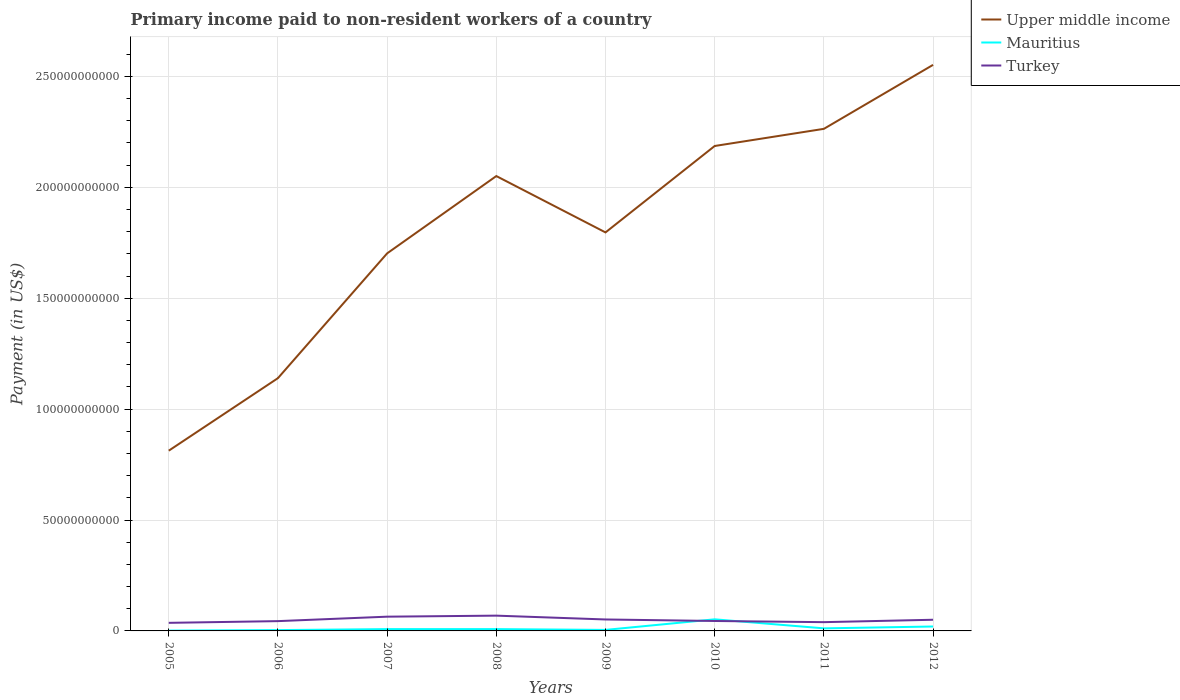Is the number of lines equal to the number of legend labels?
Give a very brief answer. Yes. Across all years, what is the maximum amount paid to workers in Turkey?
Your response must be concise. 3.64e+09. What is the total amount paid to workers in Upper middle income in the graph?
Offer a terse response. -1.45e+11. What is the difference between the highest and the second highest amount paid to workers in Turkey?
Give a very brief answer. 3.24e+09. Is the amount paid to workers in Turkey strictly greater than the amount paid to workers in Upper middle income over the years?
Provide a succinct answer. Yes. How many lines are there?
Give a very brief answer. 3. How many years are there in the graph?
Give a very brief answer. 8. What is the difference between two consecutive major ticks on the Y-axis?
Provide a short and direct response. 5.00e+1. Are the values on the major ticks of Y-axis written in scientific E-notation?
Your response must be concise. No. Does the graph contain any zero values?
Give a very brief answer. No. Does the graph contain grids?
Offer a very short reply. Yes. What is the title of the graph?
Offer a very short reply. Primary income paid to non-resident workers of a country. Does "Pacific island small states" appear as one of the legend labels in the graph?
Offer a terse response. No. What is the label or title of the Y-axis?
Your response must be concise. Payment (in US$). What is the Payment (in US$) in Upper middle income in 2005?
Offer a terse response. 8.13e+1. What is the Payment (in US$) in Mauritius in 2005?
Offer a very short reply. 1.43e+08. What is the Payment (in US$) in Turkey in 2005?
Provide a succinct answer. 3.64e+09. What is the Payment (in US$) in Upper middle income in 2006?
Keep it short and to the point. 1.14e+11. What is the Payment (in US$) of Mauritius in 2006?
Make the answer very short. 3.74e+08. What is the Payment (in US$) of Turkey in 2006?
Make the answer very short. 4.42e+09. What is the Payment (in US$) of Upper middle income in 2007?
Make the answer very short. 1.70e+11. What is the Payment (in US$) in Mauritius in 2007?
Ensure brevity in your answer.  8.16e+08. What is the Payment (in US$) in Turkey in 2007?
Your answer should be very brief. 6.42e+09. What is the Payment (in US$) of Upper middle income in 2008?
Offer a very short reply. 2.05e+11. What is the Payment (in US$) in Mauritius in 2008?
Offer a very short reply. 8.20e+08. What is the Payment (in US$) in Turkey in 2008?
Give a very brief answer. 6.89e+09. What is the Payment (in US$) in Upper middle income in 2009?
Ensure brevity in your answer.  1.80e+11. What is the Payment (in US$) in Mauritius in 2009?
Keep it short and to the point. 4.58e+08. What is the Payment (in US$) in Turkey in 2009?
Offer a very short reply. 5.16e+09. What is the Payment (in US$) in Upper middle income in 2010?
Your response must be concise. 2.19e+11. What is the Payment (in US$) of Mauritius in 2010?
Offer a terse response. 5.23e+09. What is the Payment (in US$) of Turkey in 2010?
Offer a very short reply. 4.48e+09. What is the Payment (in US$) of Upper middle income in 2011?
Provide a succinct answer. 2.26e+11. What is the Payment (in US$) in Mauritius in 2011?
Make the answer very short. 1.16e+09. What is the Payment (in US$) of Turkey in 2011?
Offer a terse response. 3.95e+09. What is the Payment (in US$) in Upper middle income in 2012?
Your answer should be very brief. 2.55e+11. What is the Payment (in US$) in Mauritius in 2012?
Offer a terse response. 1.99e+09. What is the Payment (in US$) in Turkey in 2012?
Your response must be concise. 5.03e+09. Across all years, what is the maximum Payment (in US$) of Upper middle income?
Provide a succinct answer. 2.55e+11. Across all years, what is the maximum Payment (in US$) in Mauritius?
Offer a terse response. 5.23e+09. Across all years, what is the maximum Payment (in US$) of Turkey?
Your answer should be compact. 6.89e+09. Across all years, what is the minimum Payment (in US$) in Upper middle income?
Keep it short and to the point. 8.13e+1. Across all years, what is the minimum Payment (in US$) of Mauritius?
Provide a short and direct response. 1.43e+08. Across all years, what is the minimum Payment (in US$) in Turkey?
Make the answer very short. 3.64e+09. What is the total Payment (in US$) in Upper middle income in the graph?
Ensure brevity in your answer.  1.45e+12. What is the total Payment (in US$) of Mauritius in the graph?
Give a very brief answer. 1.10e+1. What is the total Payment (in US$) of Turkey in the graph?
Offer a very short reply. 4.00e+1. What is the difference between the Payment (in US$) in Upper middle income in 2005 and that in 2006?
Your response must be concise. -3.27e+1. What is the difference between the Payment (in US$) of Mauritius in 2005 and that in 2006?
Make the answer very short. -2.31e+08. What is the difference between the Payment (in US$) in Turkey in 2005 and that in 2006?
Your answer should be very brief. -7.74e+08. What is the difference between the Payment (in US$) of Upper middle income in 2005 and that in 2007?
Provide a succinct answer. -8.90e+1. What is the difference between the Payment (in US$) of Mauritius in 2005 and that in 2007?
Provide a succinct answer. -6.74e+08. What is the difference between the Payment (in US$) in Turkey in 2005 and that in 2007?
Offer a terse response. -2.78e+09. What is the difference between the Payment (in US$) of Upper middle income in 2005 and that in 2008?
Make the answer very short. -1.24e+11. What is the difference between the Payment (in US$) in Mauritius in 2005 and that in 2008?
Keep it short and to the point. -6.77e+08. What is the difference between the Payment (in US$) of Turkey in 2005 and that in 2008?
Offer a terse response. -3.24e+09. What is the difference between the Payment (in US$) of Upper middle income in 2005 and that in 2009?
Give a very brief answer. -9.84e+1. What is the difference between the Payment (in US$) of Mauritius in 2005 and that in 2009?
Offer a very short reply. -3.15e+08. What is the difference between the Payment (in US$) of Turkey in 2005 and that in 2009?
Your answer should be very brief. -1.52e+09. What is the difference between the Payment (in US$) of Upper middle income in 2005 and that in 2010?
Provide a succinct answer. -1.37e+11. What is the difference between the Payment (in US$) in Mauritius in 2005 and that in 2010?
Make the answer very short. -5.09e+09. What is the difference between the Payment (in US$) in Turkey in 2005 and that in 2010?
Keep it short and to the point. -8.34e+08. What is the difference between the Payment (in US$) in Upper middle income in 2005 and that in 2011?
Give a very brief answer. -1.45e+11. What is the difference between the Payment (in US$) of Mauritius in 2005 and that in 2011?
Keep it short and to the point. -1.01e+09. What is the difference between the Payment (in US$) in Turkey in 2005 and that in 2011?
Give a very brief answer. -3.08e+08. What is the difference between the Payment (in US$) of Upper middle income in 2005 and that in 2012?
Give a very brief answer. -1.74e+11. What is the difference between the Payment (in US$) in Mauritius in 2005 and that in 2012?
Give a very brief answer. -1.85e+09. What is the difference between the Payment (in US$) of Turkey in 2005 and that in 2012?
Ensure brevity in your answer.  -1.39e+09. What is the difference between the Payment (in US$) of Upper middle income in 2006 and that in 2007?
Keep it short and to the point. -5.63e+1. What is the difference between the Payment (in US$) of Mauritius in 2006 and that in 2007?
Your response must be concise. -4.42e+08. What is the difference between the Payment (in US$) in Turkey in 2006 and that in 2007?
Your answer should be compact. -2.00e+09. What is the difference between the Payment (in US$) of Upper middle income in 2006 and that in 2008?
Your answer should be very brief. -9.11e+1. What is the difference between the Payment (in US$) in Mauritius in 2006 and that in 2008?
Ensure brevity in your answer.  -4.46e+08. What is the difference between the Payment (in US$) of Turkey in 2006 and that in 2008?
Offer a terse response. -2.47e+09. What is the difference between the Payment (in US$) of Upper middle income in 2006 and that in 2009?
Your answer should be very brief. -6.57e+1. What is the difference between the Payment (in US$) of Mauritius in 2006 and that in 2009?
Offer a terse response. -8.37e+07. What is the difference between the Payment (in US$) of Turkey in 2006 and that in 2009?
Provide a short and direct response. -7.46e+08. What is the difference between the Payment (in US$) of Upper middle income in 2006 and that in 2010?
Provide a short and direct response. -1.05e+11. What is the difference between the Payment (in US$) in Mauritius in 2006 and that in 2010?
Give a very brief answer. -4.86e+09. What is the difference between the Payment (in US$) in Turkey in 2006 and that in 2010?
Offer a very short reply. -6.00e+07. What is the difference between the Payment (in US$) in Upper middle income in 2006 and that in 2011?
Your answer should be compact. -1.12e+11. What is the difference between the Payment (in US$) of Mauritius in 2006 and that in 2011?
Your answer should be compact. -7.83e+08. What is the difference between the Payment (in US$) in Turkey in 2006 and that in 2011?
Offer a terse response. 4.66e+08. What is the difference between the Payment (in US$) of Upper middle income in 2006 and that in 2012?
Offer a terse response. -1.41e+11. What is the difference between the Payment (in US$) in Mauritius in 2006 and that in 2012?
Keep it short and to the point. -1.62e+09. What is the difference between the Payment (in US$) of Turkey in 2006 and that in 2012?
Your answer should be compact. -6.16e+08. What is the difference between the Payment (in US$) of Upper middle income in 2007 and that in 2008?
Your response must be concise. -3.49e+1. What is the difference between the Payment (in US$) of Mauritius in 2007 and that in 2008?
Provide a short and direct response. -3.51e+06. What is the difference between the Payment (in US$) of Turkey in 2007 and that in 2008?
Make the answer very short. -4.66e+08. What is the difference between the Payment (in US$) in Upper middle income in 2007 and that in 2009?
Your response must be concise. -9.45e+09. What is the difference between the Payment (in US$) in Mauritius in 2007 and that in 2009?
Your answer should be very brief. 3.59e+08. What is the difference between the Payment (in US$) in Turkey in 2007 and that in 2009?
Provide a succinct answer. 1.26e+09. What is the difference between the Payment (in US$) of Upper middle income in 2007 and that in 2010?
Provide a short and direct response. -4.84e+1. What is the difference between the Payment (in US$) in Mauritius in 2007 and that in 2010?
Your response must be concise. -4.42e+09. What is the difference between the Payment (in US$) of Turkey in 2007 and that in 2010?
Make the answer very short. 1.94e+09. What is the difference between the Payment (in US$) of Upper middle income in 2007 and that in 2011?
Provide a succinct answer. -5.61e+1. What is the difference between the Payment (in US$) in Mauritius in 2007 and that in 2011?
Your response must be concise. -3.41e+08. What is the difference between the Payment (in US$) in Turkey in 2007 and that in 2011?
Ensure brevity in your answer.  2.47e+09. What is the difference between the Payment (in US$) in Upper middle income in 2007 and that in 2012?
Your answer should be very brief. -8.50e+1. What is the difference between the Payment (in US$) of Mauritius in 2007 and that in 2012?
Offer a terse response. -1.17e+09. What is the difference between the Payment (in US$) of Turkey in 2007 and that in 2012?
Provide a short and direct response. 1.39e+09. What is the difference between the Payment (in US$) in Upper middle income in 2008 and that in 2009?
Provide a succinct answer. 2.54e+1. What is the difference between the Payment (in US$) of Mauritius in 2008 and that in 2009?
Offer a very short reply. 3.62e+08. What is the difference between the Payment (in US$) of Turkey in 2008 and that in 2009?
Your response must be concise. 1.72e+09. What is the difference between the Payment (in US$) of Upper middle income in 2008 and that in 2010?
Your answer should be compact. -1.36e+1. What is the difference between the Payment (in US$) of Mauritius in 2008 and that in 2010?
Ensure brevity in your answer.  -4.41e+09. What is the difference between the Payment (in US$) in Turkey in 2008 and that in 2010?
Offer a very short reply. 2.41e+09. What is the difference between the Payment (in US$) in Upper middle income in 2008 and that in 2011?
Offer a terse response. -2.13e+1. What is the difference between the Payment (in US$) in Mauritius in 2008 and that in 2011?
Make the answer very short. -3.37e+08. What is the difference between the Payment (in US$) in Turkey in 2008 and that in 2011?
Your answer should be very brief. 2.94e+09. What is the difference between the Payment (in US$) in Upper middle income in 2008 and that in 2012?
Make the answer very short. -5.01e+1. What is the difference between the Payment (in US$) in Mauritius in 2008 and that in 2012?
Provide a short and direct response. -1.17e+09. What is the difference between the Payment (in US$) in Turkey in 2008 and that in 2012?
Give a very brief answer. 1.86e+09. What is the difference between the Payment (in US$) in Upper middle income in 2009 and that in 2010?
Ensure brevity in your answer.  -3.90e+1. What is the difference between the Payment (in US$) of Mauritius in 2009 and that in 2010?
Make the answer very short. -4.77e+09. What is the difference between the Payment (in US$) of Turkey in 2009 and that in 2010?
Ensure brevity in your answer.  6.86e+08. What is the difference between the Payment (in US$) of Upper middle income in 2009 and that in 2011?
Offer a very short reply. -4.67e+1. What is the difference between the Payment (in US$) in Mauritius in 2009 and that in 2011?
Provide a succinct answer. -6.99e+08. What is the difference between the Payment (in US$) in Turkey in 2009 and that in 2011?
Make the answer very short. 1.21e+09. What is the difference between the Payment (in US$) of Upper middle income in 2009 and that in 2012?
Provide a short and direct response. -7.55e+1. What is the difference between the Payment (in US$) in Mauritius in 2009 and that in 2012?
Your response must be concise. -1.53e+09. What is the difference between the Payment (in US$) of Turkey in 2009 and that in 2012?
Ensure brevity in your answer.  1.30e+08. What is the difference between the Payment (in US$) in Upper middle income in 2010 and that in 2011?
Your answer should be very brief. -7.73e+09. What is the difference between the Payment (in US$) of Mauritius in 2010 and that in 2011?
Your answer should be very brief. 4.07e+09. What is the difference between the Payment (in US$) in Turkey in 2010 and that in 2011?
Your response must be concise. 5.26e+08. What is the difference between the Payment (in US$) of Upper middle income in 2010 and that in 2012?
Your response must be concise. -3.66e+1. What is the difference between the Payment (in US$) in Mauritius in 2010 and that in 2012?
Your response must be concise. 3.24e+09. What is the difference between the Payment (in US$) of Turkey in 2010 and that in 2012?
Offer a terse response. -5.56e+08. What is the difference between the Payment (in US$) in Upper middle income in 2011 and that in 2012?
Provide a succinct answer. -2.88e+1. What is the difference between the Payment (in US$) of Mauritius in 2011 and that in 2012?
Your response must be concise. -8.34e+08. What is the difference between the Payment (in US$) of Turkey in 2011 and that in 2012?
Keep it short and to the point. -1.08e+09. What is the difference between the Payment (in US$) in Upper middle income in 2005 and the Payment (in US$) in Mauritius in 2006?
Keep it short and to the point. 8.09e+1. What is the difference between the Payment (in US$) in Upper middle income in 2005 and the Payment (in US$) in Turkey in 2006?
Provide a succinct answer. 7.68e+1. What is the difference between the Payment (in US$) of Mauritius in 2005 and the Payment (in US$) of Turkey in 2006?
Your response must be concise. -4.28e+09. What is the difference between the Payment (in US$) of Upper middle income in 2005 and the Payment (in US$) of Mauritius in 2007?
Offer a very short reply. 8.05e+1. What is the difference between the Payment (in US$) of Upper middle income in 2005 and the Payment (in US$) of Turkey in 2007?
Provide a succinct answer. 7.48e+1. What is the difference between the Payment (in US$) in Mauritius in 2005 and the Payment (in US$) in Turkey in 2007?
Make the answer very short. -6.28e+09. What is the difference between the Payment (in US$) in Upper middle income in 2005 and the Payment (in US$) in Mauritius in 2008?
Provide a short and direct response. 8.04e+1. What is the difference between the Payment (in US$) of Upper middle income in 2005 and the Payment (in US$) of Turkey in 2008?
Make the answer very short. 7.44e+1. What is the difference between the Payment (in US$) of Mauritius in 2005 and the Payment (in US$) of Turkey in 2008?
Your response must be concise. -6.75e+09. What is the difference between the Payment (in US$) in Upper middle income in 2005 and the Payment (in US$) in Mauritius in 2009?
Your answer should be compact. 8.08e+1. What is the difference between the Payment (in US$) in Upper middle income in 2005 and the Payment (in US$) in Turkey in 2009?
Offer a terse response. 7.61e+1. What is the difference between the Payment (in US$) in Mauritius in 2005 and the Payment (in US$) in Turkey in 2009?
Give a very brief answer. -5.02e+09. What is the difference between the Payment (in US$) of Upper middle income in 2005 and the Payment (in US$) of Mauritius in 2010?
Offer a terse response. 7.60e+1. What is the difference between the Payment (in US$) in Upper middle income in 2005 and the Payment (in US$) in Turkey in 2010?
Offer a very short reply. 7.68e+1. What is the difference between the Payment (in US$) of Mauritius in 2005 and the Payment (in US$) of Turkey in 2010?
Offer a very short reply. -4.34e+09. What is the difference between the Payment (in US$) in Upper middle income in 2005 and the Payment (in US$) in Mauritius in 2011?
Offer a terse response. 8.01e+1. What is the difference between the Payment (in US$) of Upper middle income in 2005 and the Payment (in US$) of Turkey in 2011?
Offer a terse response. 7.73e+1. What is the difference between the Payment (in US$) of Mauritius in 2005 and the Payment (in US$) of Turkey in 2011?
Offer a very short reply. -3.81e+09. What is the difference between the Payment (in US$) in Upper middle income in 2005 and the Payment (in US$) in Mauritius in 2012?
Offer a terse response. 7.93e+1. What is the difference between the Payment (in US$) of Upper middle income in 2005 and the Payment (in US$) of Turkey in 2012?
Ensure brevity in your answer.  7.62e+1. What is the difference between the Payment (in US$) of Mauritius in 2005 and the Payment (in US$) of Turkey in 2012?
Your answer should be very brief. -4.89e+09. What is the difference between the Payment (in US$) of Upper middle income in 2006 and the Payment (in US$) of Mauritius in 2007?
Make the answer very short. 1.13e+11. What is the difference between the Payment (in US$) of Upper middle income in 2006 and the Payment (in US$) of Turkey in 2007?
Ensure brevity in your answer.  1.08e+11. What is the difference between the Payment (in US$) of Mauritius in 2006 and the Payment (in US$) of Turkey in 2007?
Ensure brevity in your answer.  -6.05e+09. What is the difference between the Payment (in US$) in Upper middle income in 2006 and the Payment (in US$) in Mauritius in 2008?
Your answer should be compact. 1.13e+11. What is the difference between the Payment (in US$) of Upper middle income in 2006 and the Payment (in US$) of Turkey in 2008?
Make the answer very short. 1.07e+11. What is the difference between the Payment (in US$) in Mauritius in 2006 and the Payment (in US$) in Turkey in 2008?
Your answer should be very brief. -6.52e+09. What is the difference between the Payment (in US$) of Upper middle income in 2006 and the Payment (in US$) of Mauritius in 2009?
Give a very brief answer. 1.14e+11. What is the difference between the Payment (in US$) of Upper middle income in 2006 and the Payment (in US$) of Turkey in 2009?
Provide a short and direct response. 1.09e+11. What is the difference between the Payment (in US$) of Mauritius in 2006 and the Payment (in US$) of Turkey in 2009?
Offer a terse response. -4.79e+09. What is the difference between the Payment (in US$) of Upper middle income in 2006 and the Payment (in US$) of Mauritius in 2010?
Provide a short and direct response. 1.09e+11. What is the difference between the Payment (in US$) in Upper middle income in 2006 and the Payment (in US$) in Turkey in 2010?
Your response must be concise. 1.09e+11. What is the difference between the Payment (in US$) of Mauritius in 2006 and the Payment (in US$) of Turkey in 2010?
Offer a very short reply. -4.10e+09. What is the difference between the Payment (in US$) in Upper middle income in 2006 and the Payment (in US$) in Mauritius in 2011?
Give a very brief answer. 1.13e+11. What is the difference between the Payment (in US$) in Upper middle income in 2006 and the Payment (in US$) in Turkey in 2011?
Offer a terse response. 1.10e+11. What is the difference between the Payment (in US$) in Mauritius in 2006 and the Payment (in US$) in Turkey in 2011?
Provide a short and direct response. -3.58e+09. What is the difference between the Payment (in US$) in Upper middle income in 2006 and the Payment (in US$) in Mauritius in 2012?
Ensure brevity in your answer.  1.12e+11. What is the difference between the Payment (in US$) of Upper middle income in 2006 and the Payment (in US$) of Turkey in 2012?
Your response must be concise. 1.09e+11. What is the difference between the Payment (in US$) of Mauritius in 2006 and the Payment (in US$) of Turkey in 2012?
Offer a very short reply. -4.66e+09. What is the difference between the Payment (in US$) in Upper middle income in 2007 and the Payment (in US$) in Mauritius in 2008?
Keep it short and to the point. 1.69e+11. What is the difference between the Payment (in US$) in Upper middle income in 2007 and the Payment (in US$) in Turkey in 2008?
Provide a short and direct response. 1.63e+11. What is the difference between the Payment (in US$) of Mauritius in 2007 and the Payment (in US$) of Turkey in 2008?
Give a very brief answer. -6.07e+09. What is the difference between the Payment (in US$) of Upper middle income in 2007 and the Payment (in US$) of Mauritius in 2009?
Offer a terse response. 1.70e+11. What is the difference between the Payment (in US$) in Upper middle income in 2007 and the Payment (in US$) in Turkey in 2009?
Provide a succinct answer. 1.65e+11. What is the difference between the Payment (in US$) in Mauritius in 2007 and the Payment (in US$) in Turkey in 2009?
Your answer should be very brief. -4.35e+09. What is the difference between the Payment (in US$) of Upper middle income in 2007 and the Payment (in US$) of Mauritius in 2010?
Keep it short and to the point. 1.65e+11. What is the difference between the Payment (in US$) in Upper middle income in 2007 and the Payment (in US$) in Turkey in 2010?
Provide a succinct answer. 1.66e+11. What is the difference between the Payment (in US$) in Mauritius in 2007 and the Payment (in US$) in Turkey in 2010?
Provide a succinct answer. -3.66e+09. What is the difference between the Payment (in US$) of Upper middle income in 2007 and the Payment (in US$) of Mauritius in 2011?
Keep it short and to the point. 1.69e+11. What is the difference between the Payment (in US$) of Upper middle income in 2007 and the Payment (in US$) of Turkey in 2011?
Keep it short and to the point. 1.66e+11. What is the difference between the Payment (in US$) in Mauritius in 2007 and the Payment (in US$) in Turkey in 2011?
Keep it short and to the point. -3.14e+09. What is the difference between the Payment (in US$) in Upper middle income in 2007 and the Payment (in US$) in Mauritius in 2012?
Your answer should be very brief. 1.68e+11. What is the difference between the Payment (in US$) in Upper middle income in 2007 and the Payment (in US$) in Turkey in 2012?
Provide a short and direct response. 1.65e+11. What is the difference between the Payment (in US$) of Mauritius in 2007 and the Payment (in US$) of Turkey in 2012?
Your answer should be compact. -4.22e+09. What is the difference between the Payment (in US$) in Upper middle income in 2008 and the Payment (in US$) in Mauritius in 2009?
Ensure brevity in your answer.  2.05e+11. What is the difference between the Payment (in US$) in Upper middle income in 2008 and the Payment (in US$) in Turkey in 2009?
Your response must be concise. 2.00e+11. What is the difference between the Payment (in US$) in Mauritius in 2008 and the Payment (in US$) in Turkey in 2009?
Keep it short and to the point. -4.34e+09. What is the difference between the Payment (in US$) of Upper middle income in 2008 and the Payment (in US$) of Mauritius in 2010?
Make the answer very short. 2.00e+11. What is the difference between the Payment (in US$) of Upper middle income in 2008 and the Payment (in US$) of Turkey in 2010?
Provide a succinct answer. 2.01e+11. What is the difference between the Payment (in US$) in Mauritius in 2008 and the Payment (in US$) in Turkey in 2010?
Your answer should be compact. -3.66e+09. What is the difference between the Payment (in US$) in Upper middle income in 2008 and the Payment (in US$) in Mauritius in 2011?
Your answer should be compact. 2.04e+11. What is the difference between the Payment (in US$) of Upper middle income in 2008 and the Payment (in US$) of Turkey in 2011?
Your answer should be very brief. 2.01e+11. What is the difference between the Payment (in US$) in Mauritius in 2008 and the Payment (in US$) in Turkey in 2011?
Offer a very short reply. -3.13e+09. What is the difference between the Payment (in US$) of Upper middle income in 2008 and the Payment (in US$) of Mauritius in 2012?
Your answer should be very brief. 2.03e+11. What is the difference between the Payment (in US$) in Upper middle income in 2008 and the Payment (in US$) in Turkey in 2012?
Ensure brevity in your answer.  2.00e+11. What is the difference between the Payment (in US$) of Mauritius in 2008 and the Payment (in US$) of Turkey in 2012?
Your response must be concise. -4.21e+09. What is the difference between the Payment (in US$) in Upper middle income in 2009 and the Payment (in US$) in Mauritius in 2010?
Your answer should be very brief. 1.74e+11. What is the difference between the Payment (in US$) in Upper middle income in 2009 and the Payment (in US$) in Turkey in 2010?
Ensure brevity in your answer.  1.75e+11. What is the difference between the Payment (in US$) of Mauritius in 2009 and the Payment (in US$) of Turkey in 2010?
Offer a terse response. -4.02e+09. What is the difference between the Payment (in US$) of Upper middle income in 2009 and the Payment (in US$) of Mauritius in 2011?
Ensure brevity in your answer.  1.79e+11. What is the difference between the Payment (in US$) in Upper middle income in 2009 and the Payment (in US$) in Turkey in 2011?
Your response must be concise. 1.76e+11. What is the difference between the Payment (in US$) of Mauritius in 2009 and the Payment (in US$) of Turkey in 2011?
Offer a very short reply. -3.49e+09. What is the difference between the Payment (in US$) of Upper middle income in 2009 and the Payment (in US$) of Mauritius in 2012?
Offer a very short reply. 1.78e+11. What is the difference between the Payment (in US$) in Upper middle income in 2009 and the Payment (in US$) in Turkey in 2012?
Your answer should be very brief. 1.75e+11. What is the difference between the Payment (in US$) in Mauritius in 2009 and the Payment (in US$) in Turkey in 2012?
Give a very brief answer. -4.58e+09. What is the difference between the Payment (in US$) in Upper middle income in 2010 and the Payment (in US$) in Mauritius in 2011?
Your response must be concise. 2.17e+11. What is the difference between the Payment (in US$) in Upper middle income in 2010 and the Payment (in US$) in Turkey in 2011?
Your answer should be very brief. 2.15e+11. What is the difference between the Payment (in US$) in Mauritius in 2010 and the Payment (in US$) in Turkey in 2011?
Make the answer very short. 1.28e+09. What is the difference between the Payment (in US$) in Upper middle income in 2010 and the Payment (in US$) in Mauritius in 2012?
Your answer should be very brief. 2.17e+11. What is the difference between the Payment (in US$) in Upper middle income in 2010 and the Payment (in US$) in Turkey in 2012?
Keep it short and to the point. 2.14e+11. What is the difference between the Payment (in US$) in Mauritius in 2010 and the Payment (in US$) in Turkey in 2012?
Make the answer very short. 1.98e+08. What is the difference between the Payment (in US$) of Upper middle income in 2011 and the Payment (in US$) of Mauritius in 2012?
Your answer should be compact. 2.24e+11. What is the difference between the Payment (in US$) of Upper middle income in 2011 and the Payment (in US$) of Turkey in 2012?
Give a very brief answer. 2.21e+11. What is the difference between the Payment (in US$) in Mauritius in 2011 and the Payment (in US$) in Turkey in 2012?
Offer a very short reply. -3.88e+09. What is the average Payment (in US$) of Upper middle income per year?
Make the answer very short. 1.81e+11. What is the average Payment (in US$) of Mauritius per year?
Ensure brevity in your answer.  1.37e+09. What is the average Payment (in US$) of Turkey per year?
Make the answer very short. 5.00e+09. In the year 2005, what is the difference between the Payment (in US$) in Upper middle income and Payment (in US$) in Mauritius?
Ensure brevity in your answer.  8.11e+1. In the year 2005, what is the difference between the Payment (in US$) of Upper middle income and Payment (in US$) of Turkey?
Offer a terse response. 7.76e+1. In the year 2005, what is the difference between the Payment (in US$) of Mauritius and Payment (in US$) of Turkey?
Keep it short and to the point. -3.50e+09. In the year 2006, what is the difference between the Payment (in US$) in Upper middle income and Payment (in US$) in Mauritius?
Provide a succinct answer. 1.14e+11. In the year 2006, what is the difference between the Payment (in US$) of Upper middle income and Payment (in US$) of Turkey?
Provide a succinct answer. 1.10e+11. In the year 2006, what is the difference between the Payment (in US$) of Mauritius and Payment (in US$) of Turkey?
Your answer should be very brief. -4.04e+09. In the year 2007, what is the difference between the Payment (in US$) in Upper middle income and Payment (in US$) in Mauritius?
Offer a terse response. 1.69e+11. In the year 2007, what is the difference between the Payment (in US$) of Upper middle income and Payment (in US$) of Turkey?
Keep it short and to the point. 1.64e+11. In the year 2007, what is the difference between the Payment (in US$) of Mauritius and Payment (in US$) of Turkey?
Your answer should be compact. -5.61e+09. In the year 2008, what is the difference between the Payment (in US$) of Upper middle income and Payment (in US$) of Mauritius?
Your answer should be very brief. 2.04e+11. In the year 2008, what is the difference between the Payment (in US$) of Upper middle income and Payment (in US$) of Turkey?
Your response must be concise. 1.98e+11. In the year 2008, what is the difference between the Payment (in US$) in Mauritius and Payment (in US$) in Turkey?
Offer a terse response. -6.07e+09. In the year 2009, what is the difference between the Payment (in US$) in Upper middle income and Payment (in US$) in Mauritius?
Make the answer very short. 1.79e+11. In the year 2009, what is the difference between the Payment (in US$) in Upper middle income and Payment (in US$) in Turkey?
Your response must be concise. 1.75e+11. In the year 2009, what is the difference between the Payment (in US$) in Mauritius and Payment (in US$) in Turkey?
Make the answer very short. -4.71e+09. In the year 2010, what is the difference between the Payment (in US$) in Upper middle income and Payment (in US$) in Mauritius?
Provide a succinct answer. 2.13e+11. In the year 2010, what is the difference between the Payment (in US$) of Upper middle income and Payment (in US$) of Turkey?
Your response must be concise. 2.14e+11. In the year 2010, what is the difference between the Payment (in US$) of Mauritius and Payment (in US$) of Turkey?
Provide a succinct answer. 7.54e+08. In the year 2011, what is the difference between the Payment (in US$) of Upper middle income and Payment (in US$) of Mauritius?
Offer a very short reply. 2.25e+11. In the year 2011, what is the difference between the Payment (in US$) in Upper middle income and Payment (in US$) in Turkey?
Keep it short and to the point. 2.22e+11. In the year 2011, what is the difference between the Payment (in US$) in Mauritius and Payment (in US$) in Turkey?
Give a very brief answer. -2.80e+09. In the year 2012, what is the difference between the Payment (in US$) in Upper middle income and Payment (in US$) in Mauritius?
Your answer should be very brief. 2.53e+11. In the year 2012, what is the difference between the Payment (in US$) of Upper middle income and Payment (in US$) of Turkey?
Provide a succinct answer. 2.50e+11. In the year 2012, what is the difference between the Payment (in US$) in Mauritius and Payment (in US$) in Turkey?
Offer a very short reply. -3.04e+09. What is the ratio of the Payment (in US$) of Upper middle income in 2005 to that in 2006?
Offer a terse response. 0.71. What is the ratio of the Payment (in US$) of Mauritius in 2005 to that in 2006?
Give a very brief answer. 0.38. What is the ratio of the Payment (in US$) of Turkey in 2005 to that in 2006?
Offer a terse response. 0.82. What is the ratio of the Payment (in US$) of Upper middle income in 2005 to that in 2007?
Offer a terse response. 0.48. What is the ratio of the Payment (in US$) in Mauritius in 2005 to that in 2007?
Ensure brevity in your answer.  0.17. What is the ratio of the Payment (in US$) in Turkey in 2005 to that in 2007?
Offer a very short reply. 0.57. What is the ratio of the Payment (in US$) of Upper middle income in 2005 to that in 2008?
Provide a short and direct response. 0.4. What is the ratio of the Payment (in US$) of Mauritius in 2005 to that in 2008?
Provide a succinct answer. 0.17. What is the ratio of the Payment (in US$) in Turkey in 2005 to that in 2008?
Keep it short and to the point. 0.53. What is the ratio of the Payment (in US$) in Upper middle income in 2005 to that in 2009?
Keep it short and to the point. 0.45. What is the ratio of the Payment (in US$) of Mauritius in 2005 to that in 2009?
Your response must be concise. 0.31. What is the ratio of the Payment (in US$) of Turkey in 2005 to that in 2009?
Your answer should be very brief. 0.71. What is the ratio of the Payment (in US$) in Upper middle income in 2005 to that in 2010?
Make the answer very short. 0.37. What is the ratio of the Payment (in US$) in Mauritius in 2005 to that in 2010?
Give a very brief answer. 0.03. What is the ratio of the Payment (in US$) in Turkey in 2005 to that in 2010?
Offer a terse response. 0.81. What is the ratio of the Payment (in US$) of Upper middle income in 2005 to that in 2011?
Your answer should be very brief. 0.36. What is the ratio of the Payment (in US$) in Mauritius in 2005 to that in 2011?
Provide a succinct answer. 0.12. What is the ratio of the Payment (in US$) of Turkey in 2005 to that in 2011?
Your answer should be very brief. 0.92. What is the ratio of the Payment (in US$) of Upper middle income in 2005 to that in 2012?
Your answer should be very brief. 0.32. What is the ratio of the Payment (in US$) in Mauritius in 2005 to that in 2012?
Keep it short and to the point. 0.07. What is the ratio of the Payment (in US$) of Turkey in 2005 to that in 2012?
Keep it short and to the point. 0.72. What is the ratio of the Payment (in US$) in Upper middle income in 2006 to that in 2007?
Provide a short and direct response. 0.67. What is the ratio of the Payment (in US$) in Mauritius in 2006 to that in 2007?
Your response must be concise. 0.46. What is the ratio of the Payment (in US$) of Turkey in 2006 to that in 2007?
Your response must be concise. 0.69. What is the ratio of the Payment (in US$) of Upper middle income in 2006 to that in 2008?
Keep it short and to the point. 0.56. What is the ratio of the Payment (in US$) in Mauritius in 2006 to that in 2008?
Your answer should be compact. 0.46. What is the ratio of the Payment (in US$) of Turkey in 2006 to that in 2008?
Offer a very short reply. 0.64. What is the ratio of the Payment (in US$) in Upper middle income in 2006 to that in 2009?
Ensure brevity in your answer.  0.63. What is the ratio of the Payment (in US$) in Mauritius in 2006 to that in 2009?
Your answer should be very brief. 0.82. What is the ratio of the Payment (in US$) in Turkey in 2006 to that in 2009?
Make the answer very short. 0.86. What is the ratio of the Payment (in US$) in Upper middle income in 2006 to that in 2010?
Your answer should be compact. 0.52. What is the ratio of the Payment (in US$) of Mauritius in 2006 to that in 2010?
Offer a very short reply. 0.07. What is the ratio of the Payment (in US$) in Turkey in 2006 to that in 2010?
Your answer should be very brief. 0.99. What is the ratio of the Payment (in US$) of Upper middle income in 2006 to that in 2011?
Provide a succinct answer. 0.5. What is the ratio of the Payment (in US$) in Mauritius in 2006 to that in 2011?
Provide a short and direct response. 0.32. What is the ratio of the Payment (in US$) of Turkey in 2006 to that in 2011?
Your response must be concise. 1.12. What is the ratio of the Payment (in US$) of Upper middle income in 2006 to that in 2012?
Offer a very short reply. 0.45. What is the ratio of the Payment (in US$) in Mauritius in 2006 to that in 2012?
Provide a short and direct response. 0.19. What is the ratio of the Payment (in US$) of Turkey in 2006 to that in 2012?
Keep it short and to the point. 0.88. What is the ratio of the Payment (in US$) in Upper middle income in 2007 to that in 2008?
Provide a short and direct response. 0.83. What is the ratio of the Payment (in US$) of Turkey in 2007 to that in 2008?
Provide a succinct answer. 0.93. What is the ratio of the Payment (in US$) in Upper middle income in 2007 to that in 2009?
Your answer should be very brief. 0.95. What is the ratio of the Payment (in US$) of Mauritius in 2007 to that in 2009?
Ensure brevity in your answer.  1.78. What is the ratio of the Payment (in US$) of Turkey in 2007 to that in 2009?
Keep it short and to the point. 1.24. What is the ratio of the Payment (in US$) of Upper middle income in 2007 to that in 2010?
Provide a short and direct response. 0.78. What is the ratio of the Payment (in US$) of Mauritius in 2007 to that in 2010?
Give a very brief answer. 0.16. What is the ratio of the Payment (in US$) of Turkey in 2007 to that in 2010?
Keep it short and to the point. 1.43. What is the ratio of the Payment (in US$) in Upper middle income in 2007 to that in 2011?
Your answer should be compact. 0.75. What is the ratio of the Payment (in US$) of Mauritius in 2007 to that in 2011?
Make the answer very short. 0.71. What is the ratio of the Payment (in US$) in Turkey in 2007 to that in 2011?
Provide a succinct answer. 1.63. What is the ratio of the Payment (in US$) of Upper middle income in 2007 to that in 2012?
Provide a short and direct response. 0.67. What is the ratio of the Payment (in US$) of Mauritius in 2007 to that in 2012?
Make the answer very short. 0.41. What is the ratio of the Payment (in US$) of Turkey in 2007 to that in 2012?
Your answer should be compact. 1.28. What is the ratio of the Payment (in US$) of Upper middle income in 2008 to that in 2009?
Make the answer very short. 1.14. What is the ratio of the Payment (in US$) in Mauritius in 2008 to that in 2009?
Make the answer very short. 1.79. What is the ratio of the Payment (in US$) in Turkey in 2008 to that in 2009?
Ensure brevity in your answer.  1.33. What is the ratio of the Payment (in US$) of Upper middle income in 2008 to that in 2010?
Give a very brief answer. 0.94. What is the ratio of the Payment (in US$) of Mauritius in 2008 to that in 2010?
Your response must be concise. 0.16. What is the ratio of the Payment (in US$) in Turkey in 2008 to that in 2010?
Provide a short and direct response. 1.54. What is the ratio of the Payment (in US$) of Upper middle income in 2008 to that in 2011?
Offer a very short reply. 0.91. What is the ratio of the Payment (in US$) of Mauritius in 2008 to that in 2011?
Provide a succinct answer. 0.71. What is the ratio of the Payment (in US$) of Turkey in 2008 to that in 2011?
Offer a very short reply. 1.74. What is the ratio of the Payment (in US$) of Upper middle income in 2008 to that in 2012?
Offer a terse response. 0.8. What is the ratio of the Payment (in US$) in Mauritius in 2008 to that in 2012?
Keep it short and to the point. 0.41. What is the ratio of the Payment (in US$) in Turkey in 2008 to that in 2012?
Your answer should be very brief. 1.37. What is the ratio of the Payment (in US$) of Upper middle income in 2009 to that in 2010?
Your response must be concise. 0.82. What is the ratio of the Payment (in US$) in Mauritius in 2009 to that in 2010?
Give a very brief answer. 0.09. What is the ratio of the Payment (in US$) of Turkey in 2009 to that in 2010?
Offer a very short reply. 1.15. What is the ratio of the Payment (in US$) in Upper middle income in 2009 to that in 2011?
Ensure brevity in your answer.  0.79. What is the ratio of the Payment (in US$) of Mauritius in 2009 to that in 2011?
Your response must be concise. 0.4. What is the ratio of the Payment (in US$) in Turkey in 2009 to that in 2011?
Give a very brief answer. 1.31. What is the ratio of the Payment (in US$) in Upper middle income in 2009 to that in 2012?
Your answer should be compact. 0.7. What is the ratio of the Payment (in US$) of Mauritius in 2009 to that in 2012?
Provide a succinct answer. 0.23. What is the ratio of the Payment (in US$) of Turkey in 2009 to that in 2012?
Your answer should be very brief. 1.03. What is the ratio of the Payment (in US$) of Upper middle income in 2010 to that in 2011?
Keep it short and to the point. 0.97. What is the ratio of the Payment (in US$) of Mauritius in 2010 to that in 2011?
Your answer should be very brief. 4.52. What is the ratio of the Payment (in US$) in Turkey in 2010 to that in 2011?
Offer a terse response. 1.13. What is the ratio of the Payment (in US$) of Upper middle income in 2010 to that in 2012?
Offer a very short reply. 0.86. What is the ratio of the Payment (in US$) of Mauritius in 2010 to that in 2012?
Your response must be concise. 2.63. What is the ratio of the Payment (in US$) of Turkey in 2010 to that in 2012?
Offer a terse response. 0.89. What is the ratio of the Payment (in US$) in Upper middle income in 2011 to that in 2012?
Keep it short and to the point. 0.89. What is the ratio of the Payment (in US$) of Mauritius in 2011 to that in 2012?
Keep it short and to the point. 0.58. What is the ratio of the Payment (in US$) in Turkey in 2011 to that in 2012?
Make the answer very short. 0.79. What is the difference between the highest and the second highest Payment (in US$) of Upper middle income?
Offer a terse response. 2.88e+1. What is the difference between the highest and the second highest Payment (in US$) in Mauritius?
Your answer should be very brief. 3.24e+09. What is the difference between the highest and the second highest Payment (in US$) in Turkey?
Offer a very short reply. 4.66e+08. What is the difference between the highest and the lowest Payment (in US$) of Upper middle income?
Provide a succinct answer. 1.74e+11. What is the difference between the highest and the lowest Payment (in US$) in Mauritius?
Keep it short and to the point. 5.09e+09. What is the difference between the highest and the lowest Payment (in US$) of Turkey?
Your answer should be very brief. 3.24e+09. 